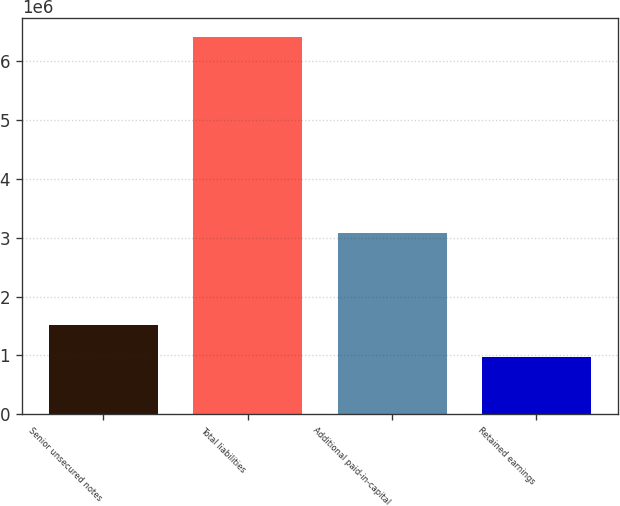Convert chart. <chart><loc_0><loc_0><loc_500><loc_500><bar_chart><fcel>Senior unsecured notes<fcel>Total liabilities<fcel>Additional paid-in-capital<fcel>Retained earnings<nl><fcel>1.52345e+06<fcel>6.41506e+06<fcel>3.07916e+06<fcel>979939<nl></chart> 